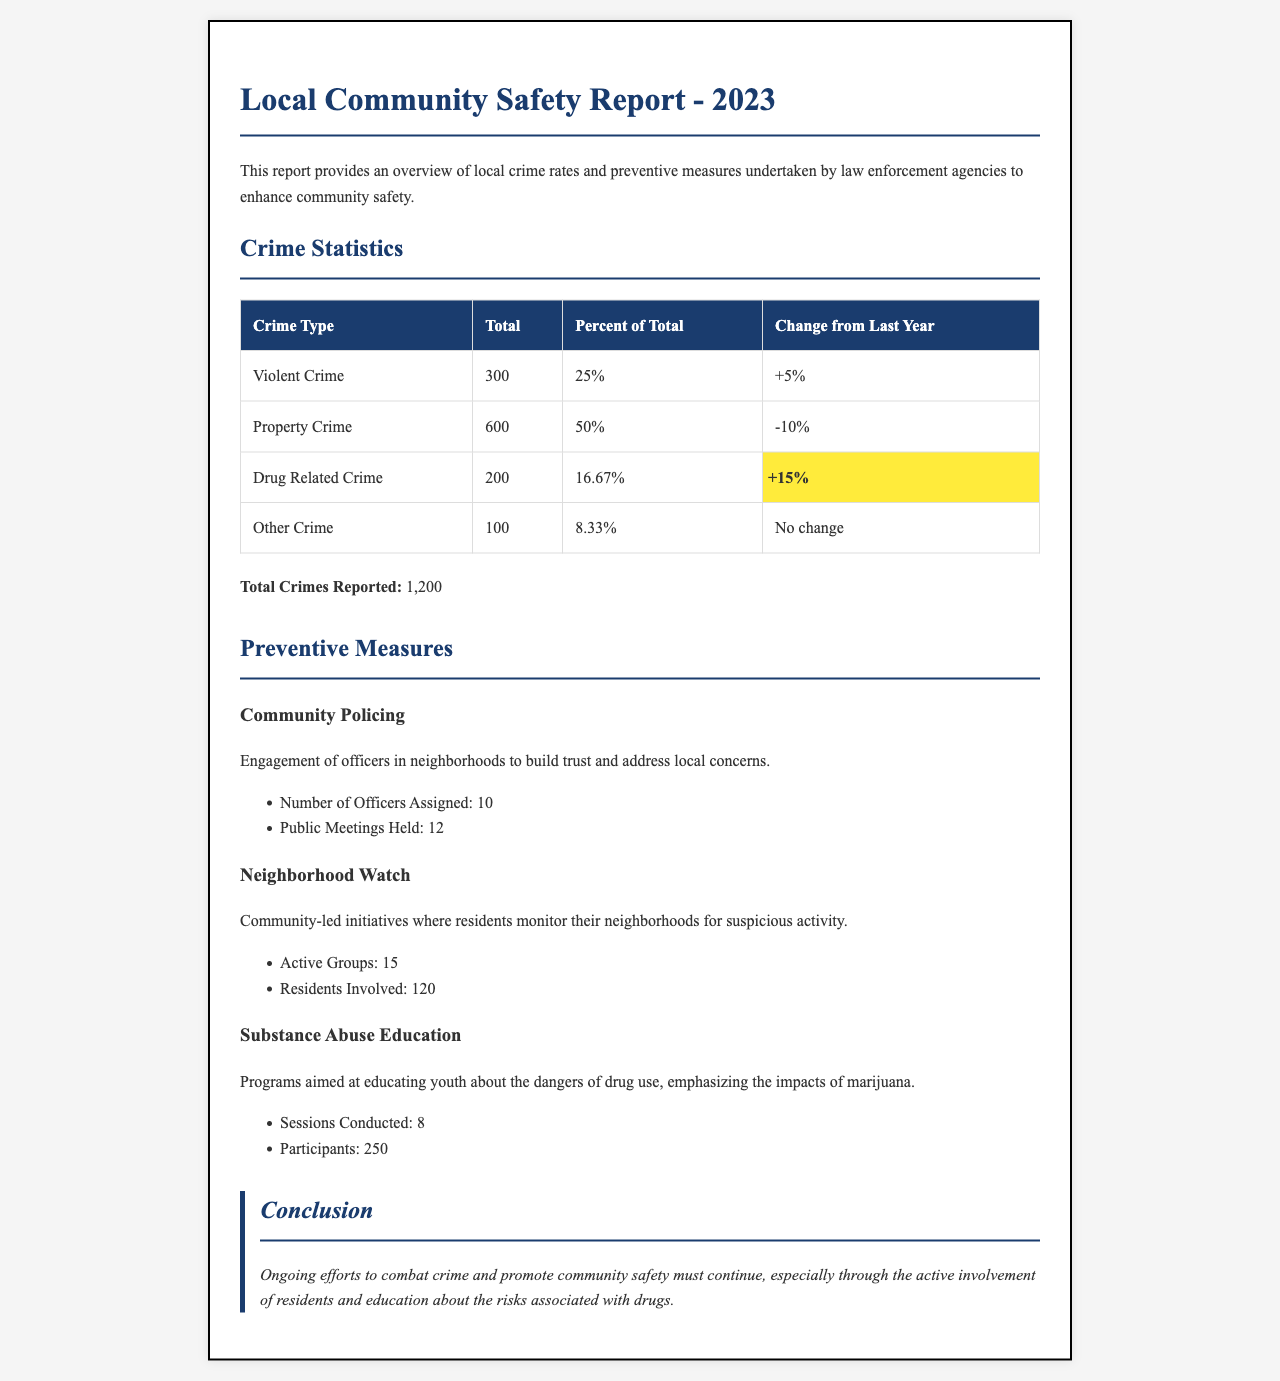What is the total number of violent crimes reported? The total number of violent crimes reported is specified in the statistics table.
Answer: 300 What percentage of total crimes does property crime represent? The percentage of total crimes represented by property crime is given in the statistics table.
Answer: 50% What is the change in drug-related crime from last year? The change in drug-related crime is mentioned in the statistics table as a percentage.
Answer: +15% How many officers are assigned to community policing? The number of officers assigned to community policing is provided under preventive measures.
Answer: 10 How many active neighborhood watch groups are there? The number of active neighborhood watch groups is listed in the preventive measures section.
Answer: 15 What is the total number of crimes reported? The total number of crimes reported is summarized at the end of the statistics section.
Answer: 1,200 How many substance abuse education sessions were conducted? The number of substance abuse education sessions is specified in the preventive measures section.
Answer: 8 What is the total number of participants in substance abuse education? The total number of participants in the substance abuse education is stated under preventive measures.
Answer: 250 What conclusion is drawn about ongoing efforts to combat crime? The conclusion about ongoing efforts is summarized in the conclusion section.
Answer: Must continue 